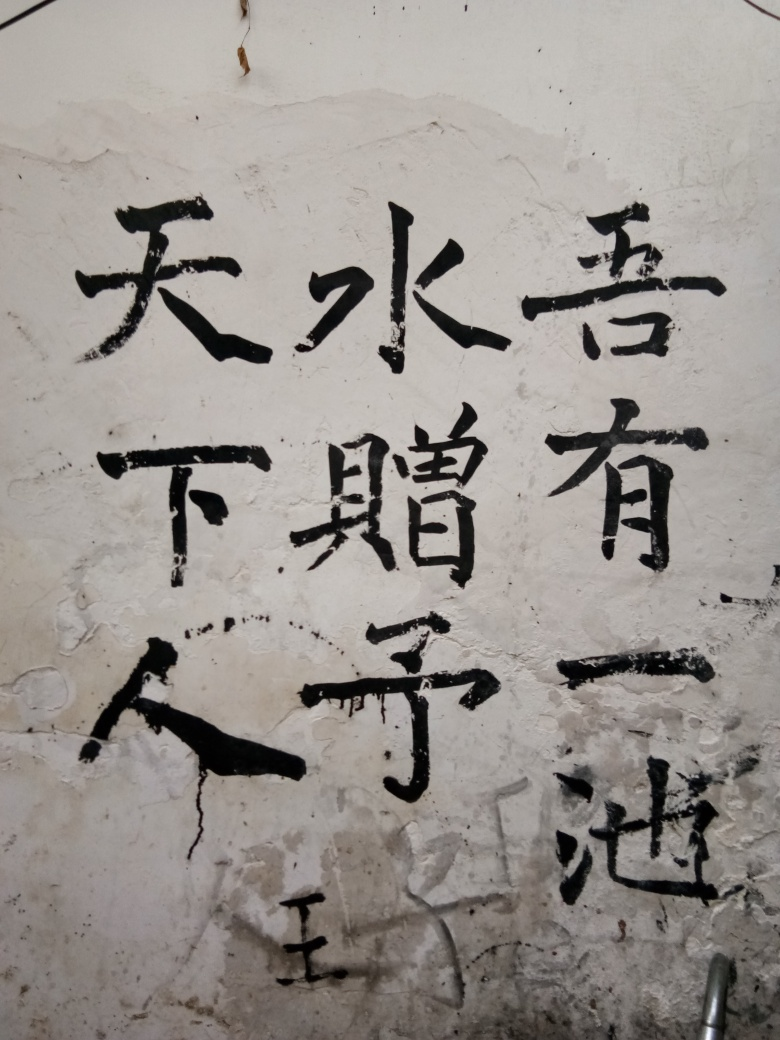What can you infer about the place where this photo was taken? The wall on which the characters are written appears aged and weathered, indicating that the photo might have been taken in an older urban area or within a building with historical significance that has preserved such traditional elements. 